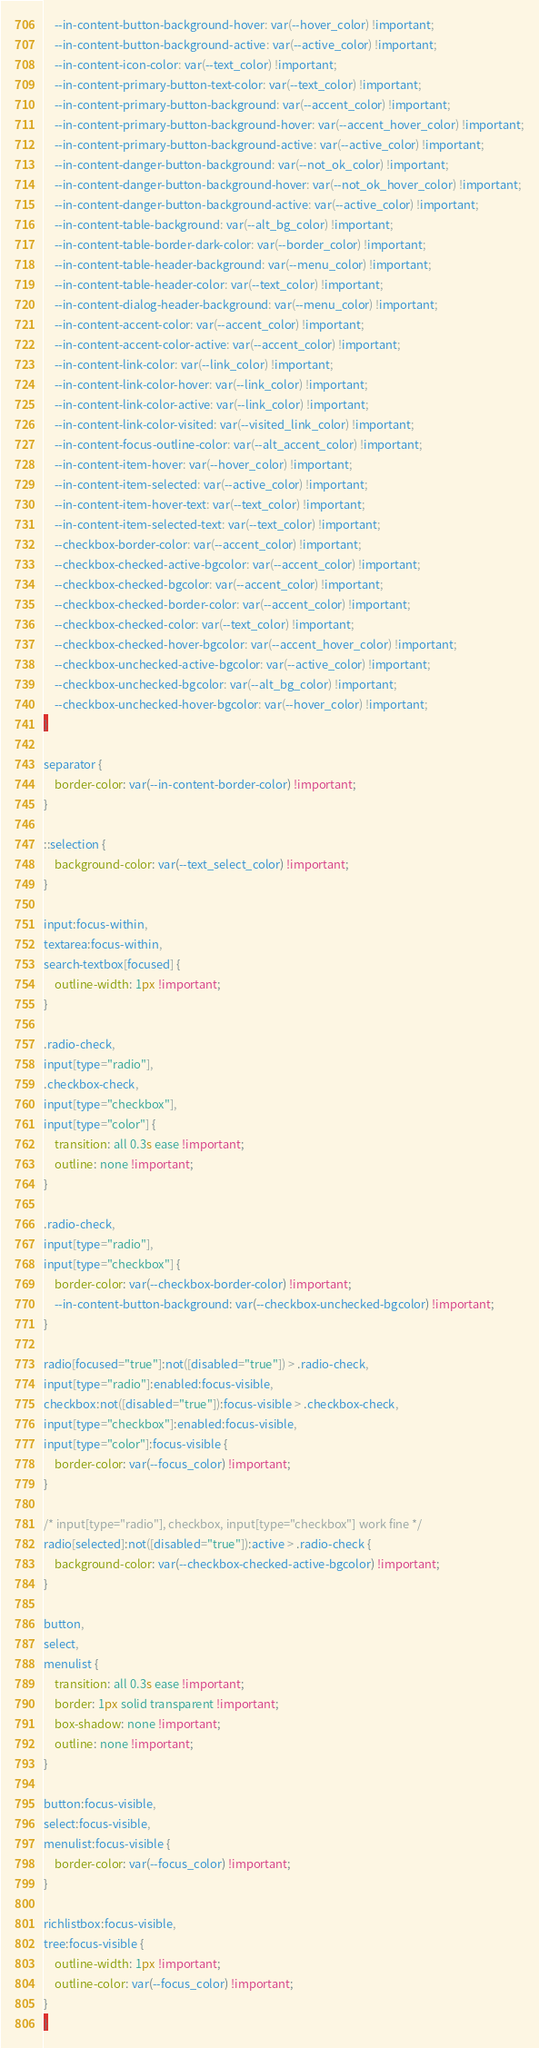<code> <loc_0><loc_0><loc_500><loc_500><_CSS_>    --in-content-button-background-hover: var(--hover_color) !important;
    --in-content-button-background-active: var(--active_color) !important;
    --in-content-icon-color: var(--text_color) !important;
    --in-content-primary-button-text-color: var(--text_color) !important;
    --in-content-primary-button-background: var(--accent_color) !important;
    --in-content-primary-button-background-hover: var(--accent_hover_color) !important;
    --in-content-primary-button-background-active: var(--active_color) !important;
    --in-content-danger-button-background: var(--not_ok_color) !important;
    --in-content-danger-button-background-hover: var(--not_ok_hover_color) !important;
    --in-content-danger-button-background-active: var(--active_color) !important;
    --in-content-table-background: var(--alt_bg_color) !important;
    --in-content-table-border-dark-color: var(--border_color) !important;
    --in-content-table-header-background: var(--menu_color) !important;
    --in-content-table-header-color: var(--text_color) !important;
    --in-content-dialog-header-background: var(--menu_color) !important;
    --in-content-accent-color: var(--accent_color) !important;
    --in-content-accent-color-active: var(--accent_color) !important;
    --in-content-link-color: var(--link_color) !important;
    --in-content-link-color-hover: var(--link_color) !important;
    --in-content-link-color-active: var(--link_color) !important;
    --in-content-link-color-visited: var(--visited_link_color) !important;
    --in-content-focus-outline-color: var(--alt_accent_color) !important;
    --in-content-item-hover: var(--hover_color) !important;
    --in-content-item-selected: var(--active_color) !important;
    --in-content-item-hover-text: var(--text_color) !important;
    --in-content-item-selected-text: var(--text_color) !important;
    --checkbox-border-color: var(--accent_color) !important;
    --checkbox-checked-active-bgcolor: var(--accent_color) !important;
    --checkbox-checked-bgcolor: var(--accent_color) !important;
    --checkbox-checked-border-color: var(--accent_color) !important;
    --checkbox-checked-color: var(--text_color) !important;
    --checkbox-checked-hover-bgcolor: var(--accent_hover_color) !important;
    --checkbox-unchecked-active-bgcolor: var(--active_color) !important;
    --checkbox-unchecked-bgcolor: var(--alt_bg_color) !important;
    --checkbox-unchecked-hover-bgcolor: var(--hover_color) !important;
}

separator {
    border-color: var(--in-content-border-color) !important;
}

::selection {
    background-color: var(--text_select_color) !important;
}

input:focus-within,
textarea:focus-within,
search-textbox[focused] {
    outline-width: 1px !important;
}

.radio-check,
input[type="radio"],
.checkbox-check,
input[type="checkbox"],
input[type="color"] {
    transition: all 0.3s ease !important;
    outline: none !important;
}

.radio-check,
input[type="radio"],
input[type="checkbox"] {
    border-color: var(--checkbox-border-color) !important;
    --in-content-button-background: var(--checkbox-unchecked-bgcolor) !important;
}

radio[focused="true"]:not([disabled="true"]) > .radio-check,
input[type="radio"]:enabled:focus-visible,
checkbox:not([disabled="true"]):focus-visible > .checkbox-check,
input[type="checkbox"]:enabled:focus-visible,
input[type="color"]:focus-visible {
    border-color: var(--focus_color) !important;
}

/* input[type="radio"], checkbox, input[type="checkbox"] work fine */
radio[selected]:not([disabled="true"]):active > .radio-check {
    background-color: var(--checkbox-checked-active-bgcolor) !important;
}

button,
select,
menulist {
    transition: all 0.3s ease !important;
    border: 1px solid transparent !important;
    box-shadow: none !important;
    outline: none !important;
}

button:focus-visible,
select:focus-visible,
menulist:focus-visible {
    border-color: var(--focus_color) !important;
}

richlistbox:focus-visible,
tree:focus-visible {
    outline-width: 1px !important;
    outline-color: var(--focus_color) !important;
}
}
</code> 